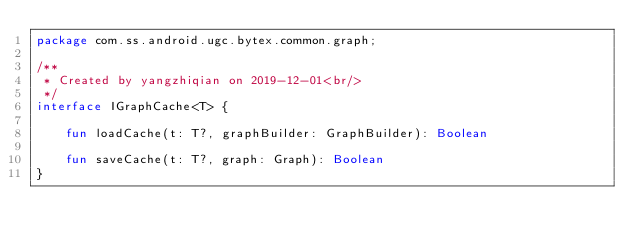<code> <loc_0><loc_0><loc_500><loc_500><_Kotlin_>package com.ss.android.ugc.bytex.common.graph;

/**
 * Created by yangzhiqian on 2019-12-01<br/>
 */
interface IGraphCache<T> {

    fun loadCache(t: T?, graphBuilder: GraphBuilder): Boolean

    fun saveCache(t: T?, graph: Graph): Boolean
}
</code> 